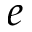<formula> <loc_0><loc_0><loc_500><loc_500>e</formula> 